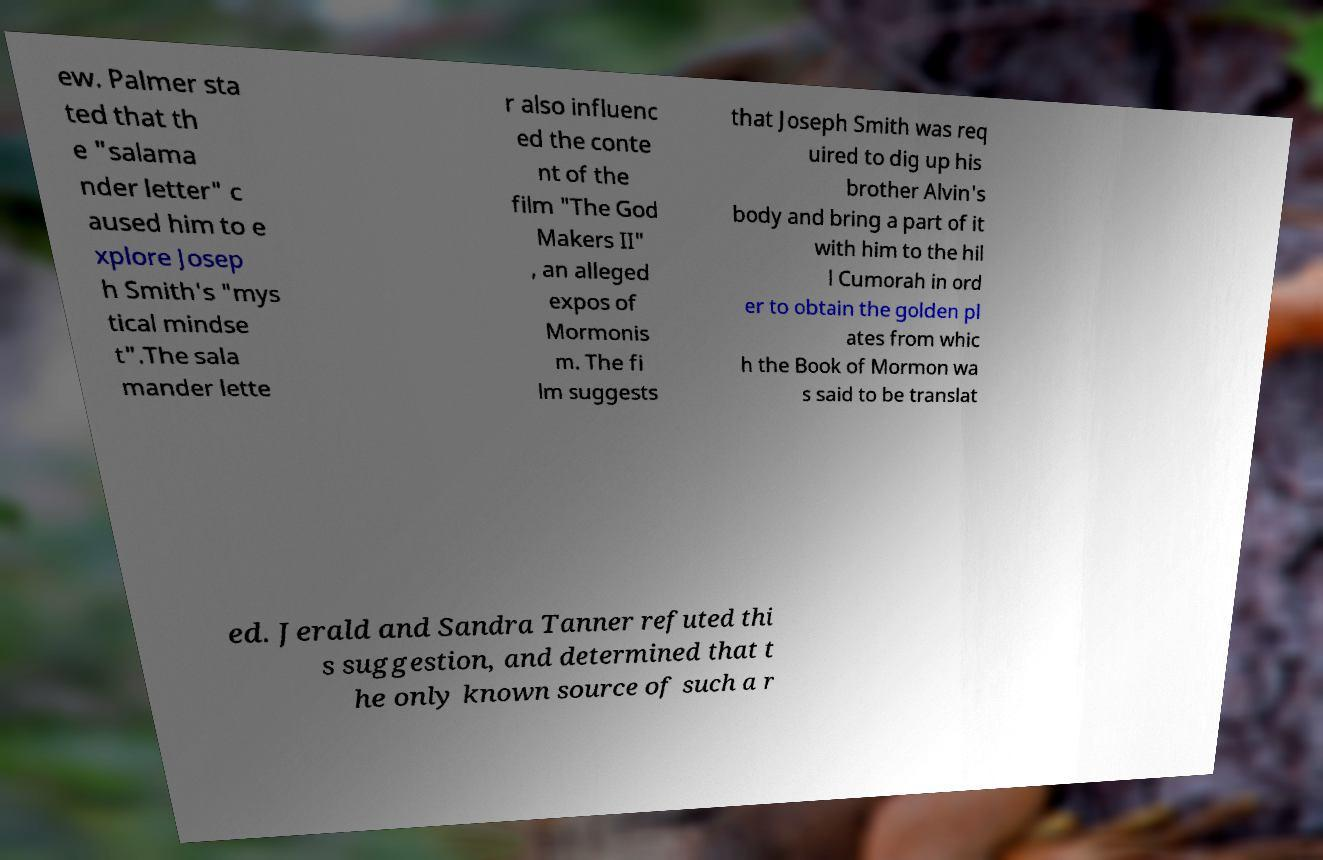For documentation purposes, I need the text within this image transcribed. Could you provide that? ew. Palmer sta ted that th e "salama nder letter" c aused him to e xplore Josep h Smith's "mys tical mindse t".The sala mander lette r also influenc ed the conte nt of the film "The God Makers II" , an alleged expos of Mormonis m. The fi lm suggests that Joseph Smith was req uired to dig up his brother Alvin's body and bring a part of it with him to the hil l Cumorah in ord er to obtain the golden pl ates from whic h the Book of Mormon wa s said to be translat ed. Jerald and Sandra Tanner refuted thi s suggestion, and determined that t he only known source of such a r 